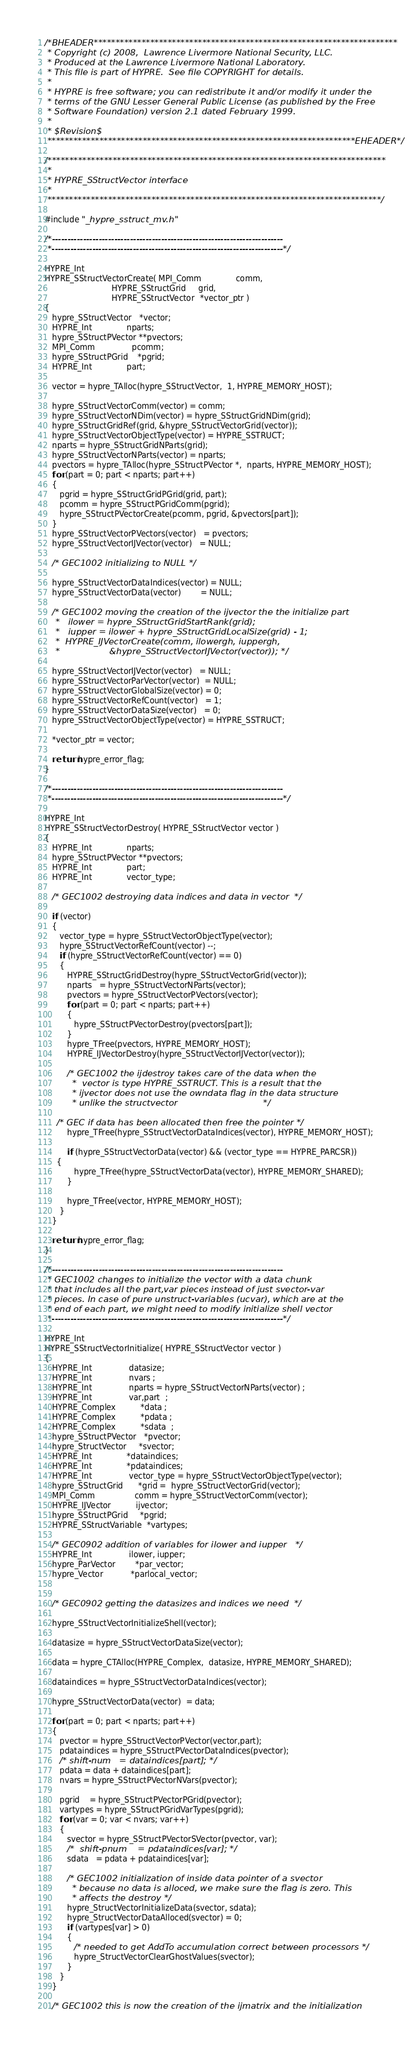<code> <loc_0><loc_0><loc_500><loc_500><_C_>/*BHEADER**********************************************************************
 * Copyright (c) 2008,  Lawrence Livermore National Security, LLC.
 * Produced at the Lawrence Livermore National Laboratory.
 * This file is part of HYPRE.  See file COPYRIGHT for details.
 *
 * HYPRE is free software; you can redistribute it and/or modify it under the
 * terms of the GNU Lesser General Public License (as published by the Free
 * Software Foundation) version 2.1 dated February 1999.
 *
 * $Revision$
 ***********************************************************************EHEADER*/

/******************************************************************************
 *
 * HYPRE_SStructVector interface
 *
 *****************************************************************************/

#include "_hypre_sstruct_mv.h"

/*--------------------------------------------------------------------------
 *--------------------------------------------------------------------------*/

HYPRE_Int
HYPRE_SStructVectorCreate( MPI_Comm              comm,
                           HYPRE_SStructGrid     grid,
                           HYPRE_SStructVector  *vector_ptr )
{
   hypre_SStructVector   *vector;
   HYPRE_Int              nparts;
   hypre_SStructPVector **pvectors;
   MPI_Comm               pcomm;
   hypre_SStructPGrid    *pgrid;
   HYPRE_Int              part;

   vector = hypre_TAlloc(hypre_SStructVector,  1, HYPRE_MEMORY_HOST);

   hypre_SStructVectorComm(vector) = comm;
   hypre_SStructVectorNDim(vector) = hypre_SStructGridNDim(grid);
   hypre_SStructGridRef(grid, &hypre_SStructVectorGrid(vector));
   hypre_SStructVectorObjectType(vector) = HYPRE_SSTRUCT;
   nparts = hypre_SStructGridNParts(grid);
   hypre_SStructVectorNParts(vector) = nparts;
   pvectors = hypre_TAlloc(hypre_SStructPVector *,  nparts, HYPRE_MEMORY_HOST);
   for (part = 0; part < nparts; part++)
   {
      pgrid = hypre_SStructGridPGrid(grid, part);
      pcomm = hypre_SStructPGridComm(pgrid);
      hypre_SStructPVectorCreate(pcomm, pgrid, &pvectors[part]);
   }
   hypre_SStructVectorPVectors(vector)   = pvectors;
   hypre_SStructVectorIJVector(vector)   = NULL;

   /* GEC1002 initializing to NULL */

   hypre_SStructVectorDataIndices(vector) = NULL;
   hypre_SStructVectorData(vector)        = NULL;

   /* GEC1002 moving the creation of the ijvector the the initialize part  
    *   ilower = hypre_SStructGridStartRank(grid); 
    *   iupper = ilower + hypre_SStructGridLocalSize(grid) - 1;
    *  HYPRE_IJVectorCreate(comm, ilowergh, iuppergh,
    *                  &hypre_SStructVectorIJVector(vector)); */

   hypre_SStructVectorIJVector(vector)   = NULL;
   hypre_SStructVectorParVector(vector)  = NULL;
   hypre_SStructVectorGlobalSize(vector) = 0;
   hypre_SStructVectorRefCount(vector)   = 1;
   hypre_SStructVectorDataSize(vector)   = 0;
   hypre_SStructVectorObjectType(vector) = HYPRE_SSTRUCT;
 
   *vector_ptr = vector;

   return hypre_error_flag;
}

/*--------------------------------------------------------------------------
 *--------------------------------------------------------------------------*/

HYPRE_Int 
HYPRE_SStructVectorDestroy( HYPRE_SStructVector vector )
{
   HYPRE_Int              nparts;
   hypre_SStructPVector **pvectors;
   HYPRE_Int              part;
   HYPRE_Int              vector_type;

   /* GEC1002 destroying data indices and data in vector  */

   if (vector)
   {
      vector_type = hypre_SStructVectorObjectType(vector);
      hypre_SStructVectorRefCount(vector) --;
      if (hypre_SStructVectorRefCount(vector) == 0)
      {
         HYPRE_SStructGridDestroy(hypre_SStructVectorGrid(vector));
         nparts   = hypre_SStructVectorNParts(vector);
         pvectors = hypre_SStructVectorPVectors(vector);
         for (part = 0; part < nparts; part++)
         {
            hypre_SStructPVectorDestroy(pvectors[part]);
         }
         hypre_TFree(pvectors, HYPRE_MEMORY_HOST);
         HYPRE_IJVectorDestroy(hypre_SStructVectorIJVector(vector));

         /* GEC1002 the ijdestroy takes care of the data when the
          *  vector is type HYPRE_SSTRUCT. This is a result that the
          * ijvector does not use the owndata flag in the data structure
          * unlike the structvector                               */                      

	 /* GEC if data has been allocated then free the pointer */
         hypre_TFree(hypre_SStructVectorDataIndices(vector), HYPRE_MEMORY_HOST);
         
         if (hypre_SStructVectorData(vector) && (vector_type == HYPRE_PARCSR))
	 {
            hypre_TFree(hypre_SStructVectorData(vector), HYPRE_MEMORY_SHARED);
         }

         hypre_TFree(vector, HYPRE_MEMORY_HOST);
      }
   }

   return hypre_error_flag;
}

/*--------------------------------------------------------------------------
 * GEC1002 changes to initialize the vector with a data chunk
 * that includes all the part,var pieces instead of just svector-var
 * pieces. In case of pure unstruct-variables (ucvar), which are at the
 * end of each part, we might need to modify initialize shell vector
 *--------------------------------------------------------------------------*/

HYPRE_Int 
HYPRE_SStructVectorInitialize( HYPRE_SStructVector vector )
{
   HYPRE_Int               datasize;
   HYPRE_Int               nvars ;
   HYPRE_Int               nparts = hypre_SStructVectorNParts(vector) ;
   HYPRE_Int               var,part  ;
   HYPRE_Complex          *data ;
   HYPRE_Complex          *pdata ;
   HYPRE_Complex          *sdata  ;
   hypre_SStructPVector   *pvector;
   hypre_StructVector     *svector;
   HYPRE_Int              *dataindices;
   HYPRE_Int              *pdataindices;
   HYPRE_Int               vector_type = hypre_SStructVectorObjectType(vector);
   hypre_SStructGrid      *grid =  hypre_SStructVectorGrid(vector);
   MPI_Comm                comm = hypre_SStructVectorComm(vector);
   HYPRE_IJVector          ijvector;
   hypre_SStructPGrid     *pgrid;
   HYPRE_SStructVariable  *vartypes;

   /* GEC0902 addition of variables for ilower and iupper   */
   HYPRE_Int               ilower, iupper;
   hypre_ParVector        *par_vector;
   hypre_Vector           *parlocal_vector;
 

   /* GEC0902 getting the datasizes and indices we need  */

   hypre_SStructVectorInitializeShell(vector);

   datasize = hypre_SStructVectorDataSize(vector);

   data = hypre_CTAlloc(HYPRE_Complex,  datasize, HYPRE_MEMORY_SHARED);

   dataindices = hypre_SStructVectorDataIndices(vector);

   hypre_SStructVectorData(vector)  = data;
  
   for (part = 0; part < nparts; part++)
   {
      pvector = hypre_SStructVectorPVector(vector,part);
      pdataindices = hypre_SStructPVectorDataIndices(pvector);
      /* shift-num   = dataindices[part]; */
      pdata = data + dataindices[part];
      nvars = hypre_SStructPVectorNVars(pvector);

      pgrid    = hypre_SStructPVectorPGrid(pvector);
      vartypes = hypre_SStructPGridVarTypes(pgrid);
      for (var = 0; var < nvars; var++)
      {     
         svector = hypre_SStructPVectorSVector(pvector, var);
         /*  shift-pnum    = pdataindices[var]; */ 
         sdata   = pdata + pdataindices[var];

         /* GEC1002 initialization of inside data pointer of a svector
          * because no data is alloced, we make sure the flag is zero. This
          * affects the destroy */
         hypre_StructVectorInitializeData(svector, sdata);
         hypre_StructVectorDataAlloced(svector) = 0;
         if (vartypes[var] > 0)
         {
            /* needed to get AddTo accumulation correct between processors */
            hypre_StructVectorClearGhostValues(svector);
         }
      }
   }
   
   /* GEC1002 this is now the creation of the ijmatrix and the initialization  </code> 